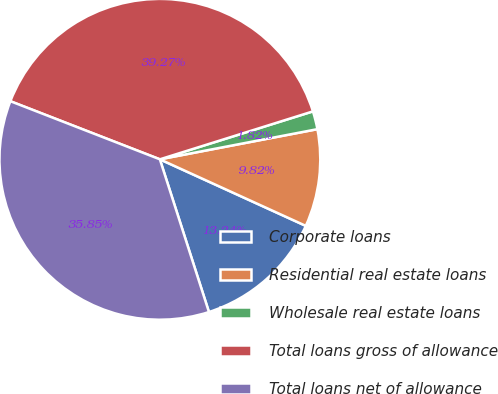Convert chart to OTSL. <chart><loc_0><loc_0><loc_500><loc_500><pie_chart><fcel>Corporate loans<fcel>Residential real estate loans<fcel>Wholesale real estate loans<fcel>Total loans gross of allowance<fcel>Total loans net of allowance<nl><fcel>13.24%<fcel>9.82%<fcel>1.82%<fcel>39.27%<fcel>35.85%<nl></chart> 